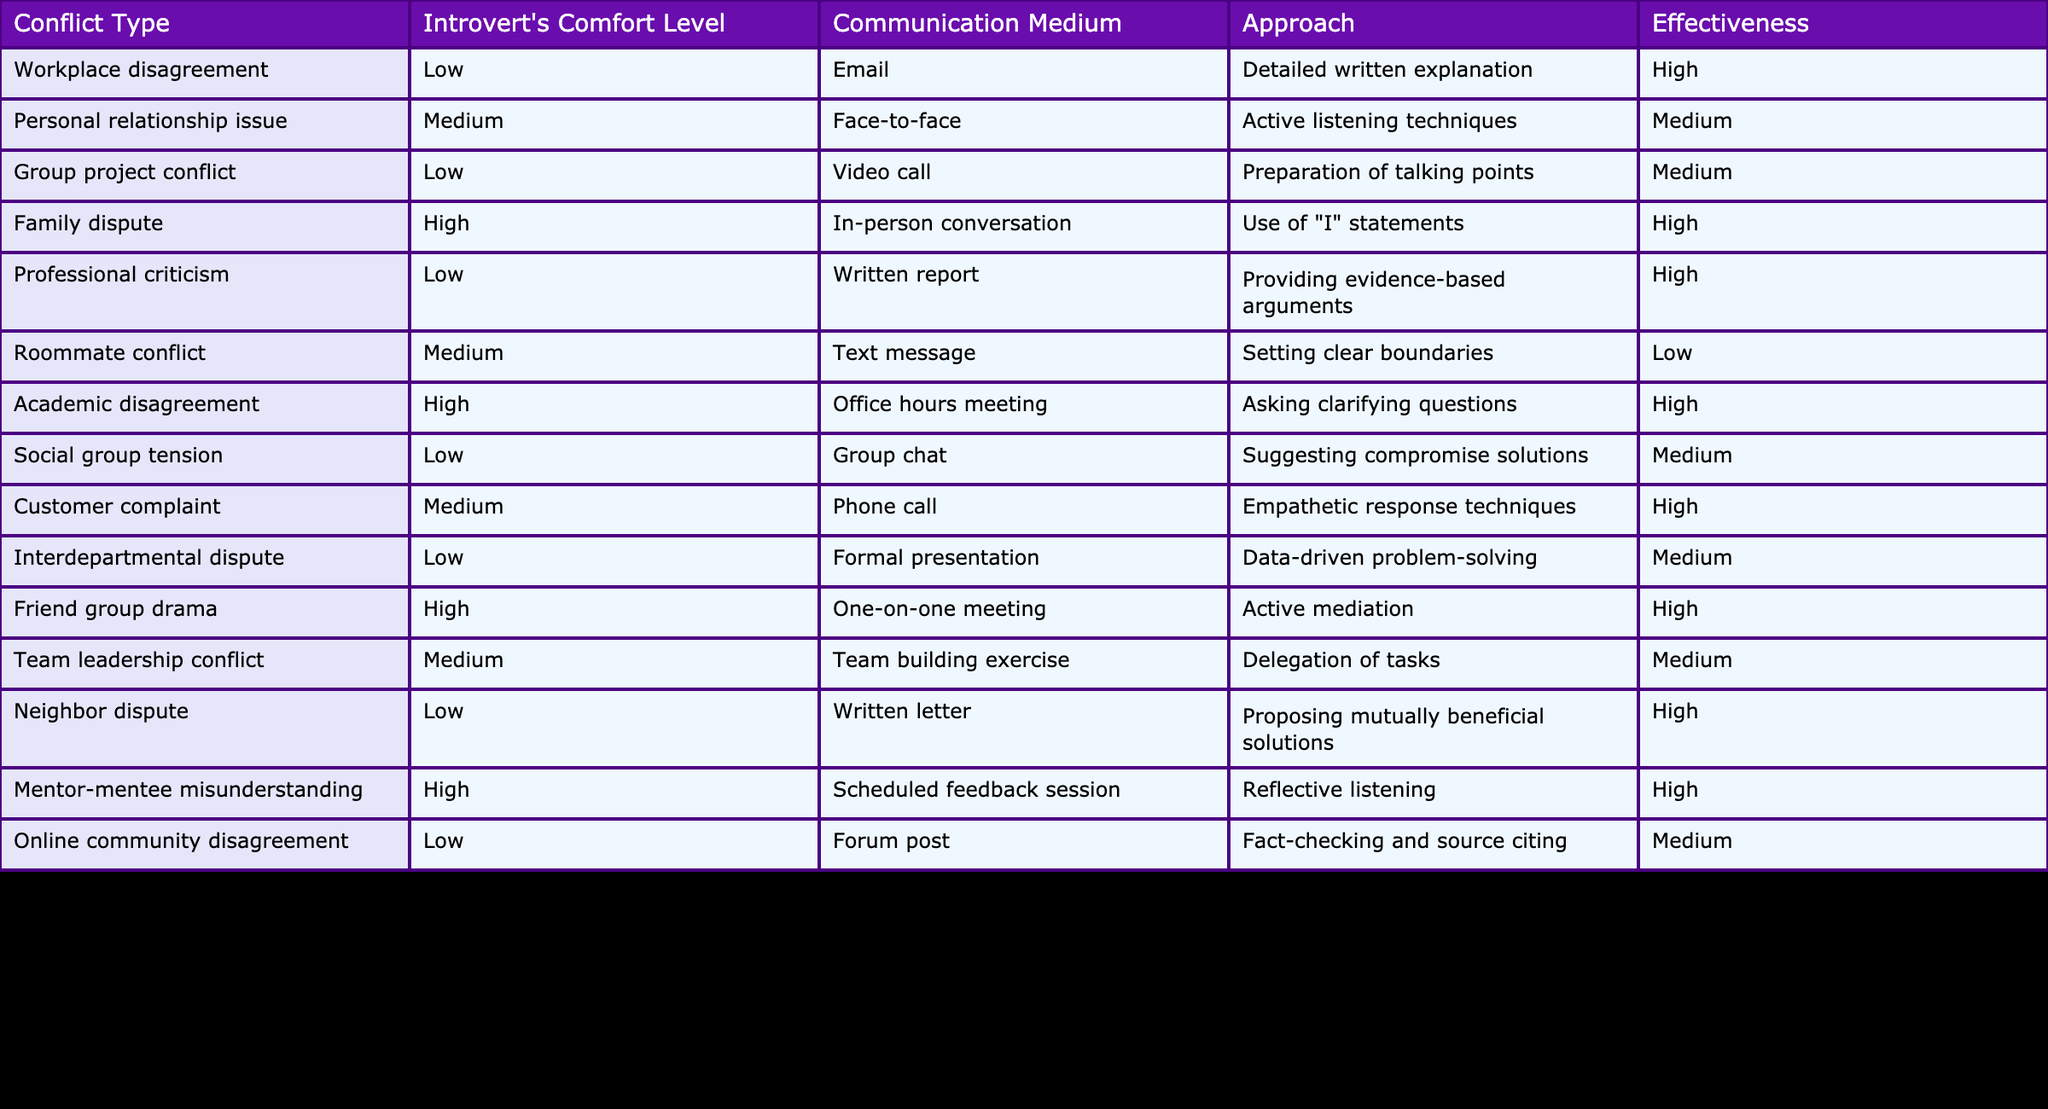What is the effectiveness of the approach used in the family dispute? The table indicates that the approach for family dispute is "Use of 'I' statements," which has a listed effectiveness of "High."
Answer: High How many conflict types have a low comfort level for introverted individuals? By counting the rows where the comfort level is marked as "Low," we can identify 6 conflict types: Workplace disagreement, Group project conflict, Professional criticism, Social group tension, Interdepartmental dispute, and Online community disagreement.
Answer: 6 Is the communication medium for personal relationship issues face-to-face? The table lists the communication medium for personal relationship issues as "Face-to-face," which confirms the statement to be true.
Answer: Yes Which conflict type has the highest effectiveness rating for introverted individuals? By reviewing the effectiveness ratings, we find that both the family dispute and friend group drama have a "High" effectiveness rating, which is the highest among all approaches listed.
Answer: Family dispute and friend group drama What is the average comfort level of introverts across all conflict types listed? The comfort levels are categorized as Low (1), Medium (2), and High (3). Counting the types: 6 Low, 6 Medium, and 4 High, we calculate the total comfort level as (1*6 + 2*6 + 3*4) = 38 and find the average (38/16) ≈ 2.375, which approximates to Medium.
Answer: Medium Which conflict type has a medium communication medium and a high effectiveness rating? According to the table, the customer complaint has a medium communication medium (Phone call) and is listed as having high effectiveness.
Answer: Customer complaint Are there more conflict types that involve a low comfort level than a high comfort level? The table shows 6 conflict types with a low comfort level and 4 with a high comfort level, confirming that there are more types involving a low comfort level.
Answer: Yes What is the effectiveness of the approach that involves active listening techniques? The approach of "Active listening techniques" is specifically linked to personal relationship issues, which has a medium effectiveness rating according to the table.
Answer: Medium What are the communication mediums used for conflict types with high effectiveness? Reviewing the table, the communication mediums used for conflict types with high effectiveness are: In-person conversation, Office hours meeting, One-on-one meeting, Scheduled feedback session. Thus, they use various mediums.
Answer: In-person conversation, Office hours meeting, One-on-one meeting, Scheduled feedback session 